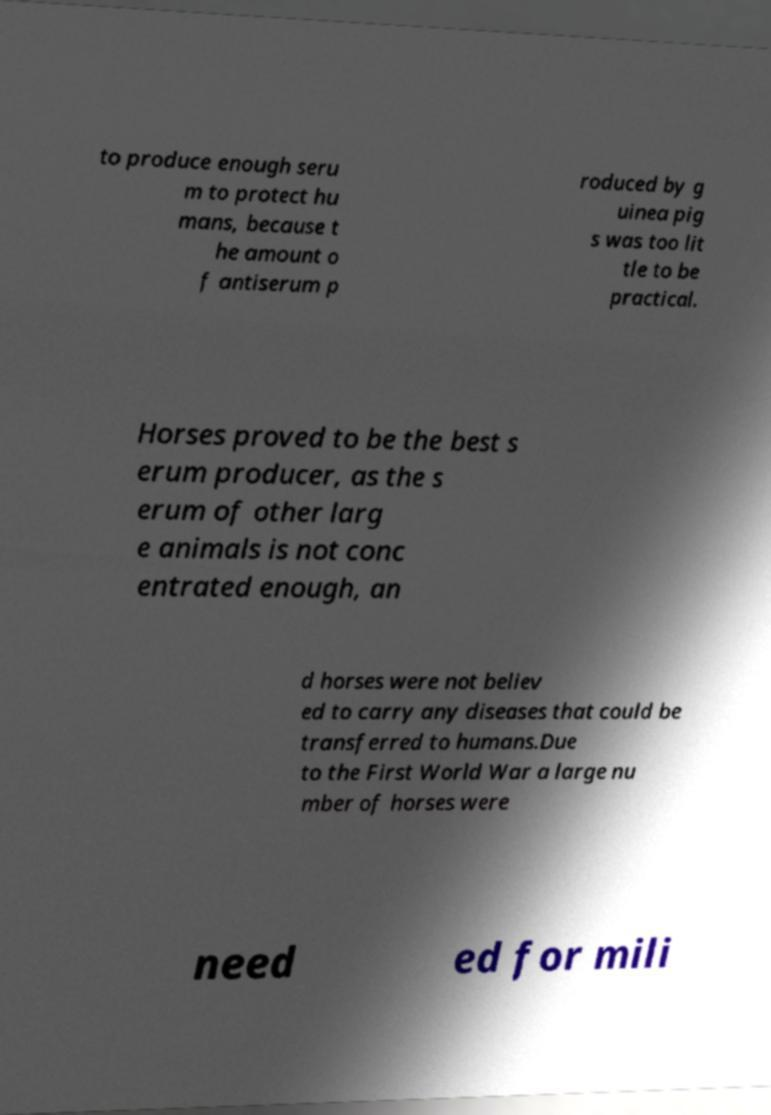Please read and relay the text visible in this image. What does it say? to produce enough seru m to protect hu mans, because t he amount o f antiserum p roduced by g uinea pig s was too lit tle to be practical. Horses proved to be the best s erum producer, as the s erum of other larg e animals is not conc entrated enough, an d horses were not believ ed to carry any diseases that could be transferred to humans.Due to the First World War a large nu mber of horses were need ed for mili 